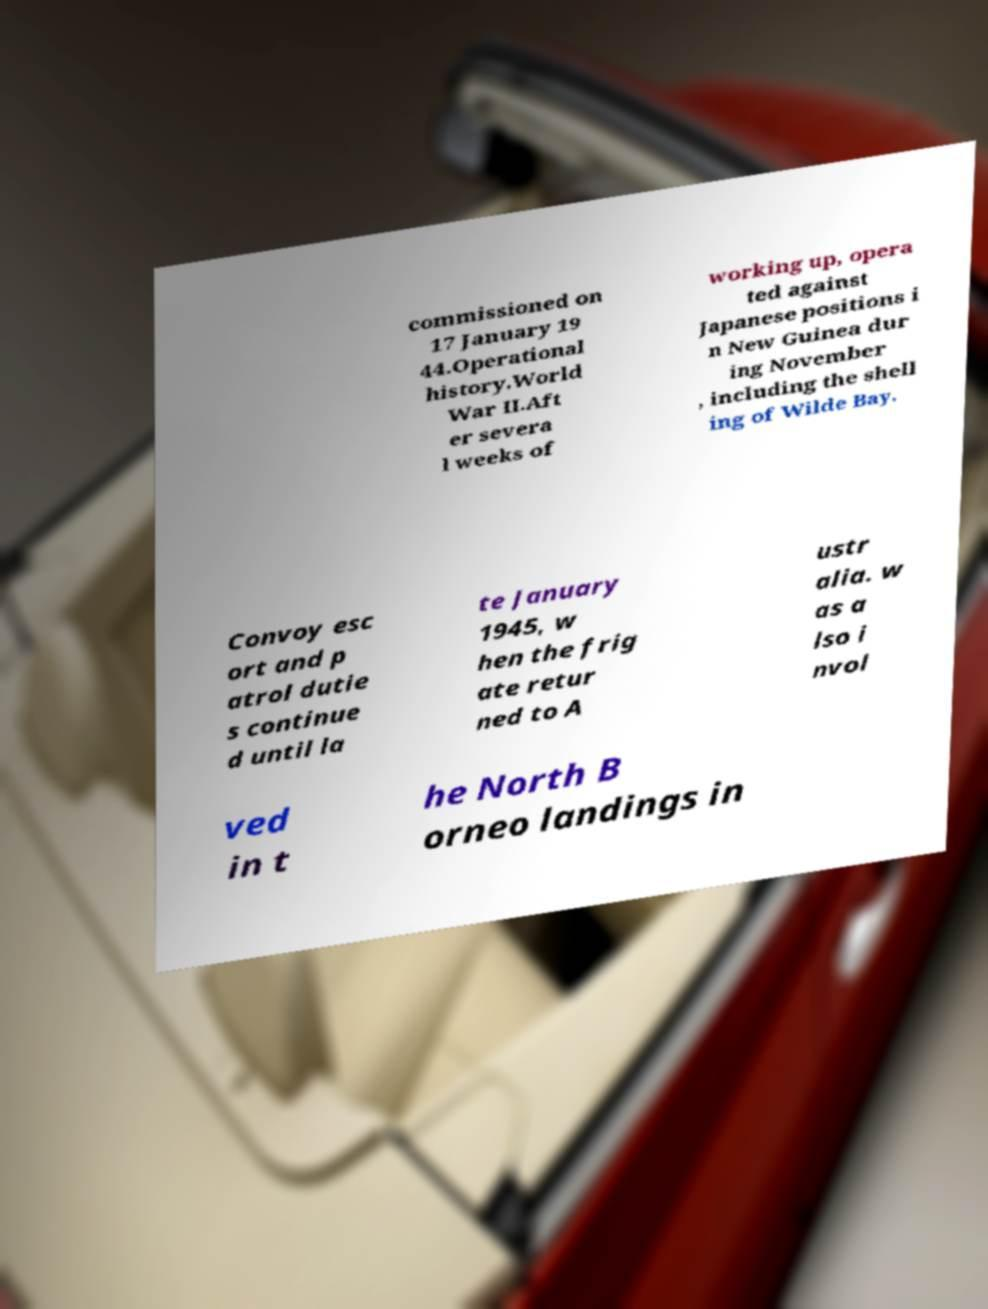Can you read and provide the text displayed in the image?This photo seems to have some interesting text. Can you extract and type it out for me? commissioned on 17 January 19 44.Operational history.World War II.Aft er severa l weeks of working up, opera ted against Japanese positions i n New Guinea dur ing November , including the shell ing of Wilde Bay. Convoy esc ort and p atrol dutie s continue d until la te January 1945, w hen the frig ate retur ned to A ustr alia. w as a lso i nvol ved in t he North B orneo landings in 